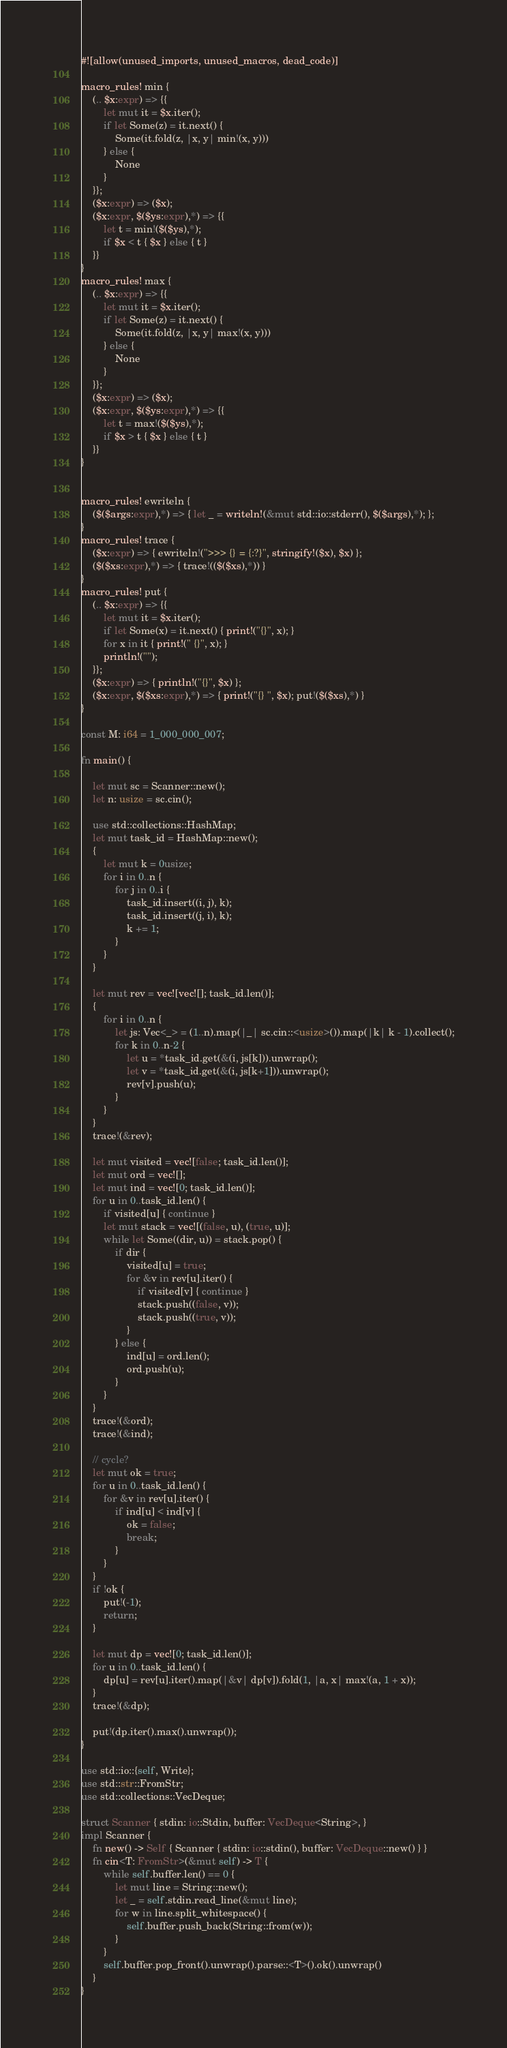<code> <loc_0><loc_0><loc_500><loc_500><_Rust_>#![allow(unused_imports, unused_macros, dead_code)]

macro_rules! min {
    (.. $x:expr) => {{
        let mut it = $x.iter();
        if let Some(z) = it.next() {
            Some(it.fold(z, |x, y| min!(x, y)))
        } else {
            None
        }
    }};
    ($x:expr) => ($x);
    ($x:expr, $($ys:expr),*) => {{
        let t = min!($($ys),*);
        if $x < t { $x } else { t }
    }}
}
macro_rules! max {
    (.. $x:expr) => {{
        let mut it = $x.iter();
        if let Some(z) = it.next() {
            Some(it.fold(z, |x, y| max!(x, y)))
        } else {
            None
        }
    }};
    ($x:expr) => ($x);
    ($x:expr, $($ys:expr),*) => {{
        let t = max!($($ys),*);
        if $x > t { $x } else { t }
    }}
}


macro_rules! ewriteln {
    ($($args:expr),*) => { let _ = writeln!(&mut std::io::stderr(), $($args),*); };
}
macro_rules! trace {
    ($x:expr) => { ewriteln!(">>> {} = {:?}", stringify!($x), $x) };
    ($($xs:expr),*) => { trace!(($($xs),*)) }
}
macro_rules! put {
    (.. $x:expr) => {{
        let mut it = $x.iter();
        if let Some(x) = it.next() { print!("{}", x); }
        for x in it { print!(" {}", x); }
        println!("");
    }};
    ($x:expr) => { println!("{}", $x) };
    ($x:expr, $($xs:expr),*) => { print!("{} ", $x); put!($($xs),*) }
}

const M: i64 = 1_000_000_007;

fn main() {

    let mut sc = Scanner::new();
    let n: usize = sc.cin();

    use std::collections::HashMap;
    let mut task_id = HashMap::new();
    {
        let mut k = 0usize;
        for i in 0..n {
            for j in 0..i {
                task_id.insert((i, j), k);
                task_id.insert((j, i), k);
                k += 1;
            }
        }
    }

    let mut rev = vec![vec![]; task_id.len()];
    {
        for i in 0..n {
            let js: Vec<_> = (1..n).map(|_| sc.cin::<usize>()).map(|k| k - 1).collect();
            for k in 0..n-2 {
                let u = *task_id.get(&(i, js[k])).unwrap();
                let v = *task_id.get(&(i, js[k+1])).unwrap();
                rev[v].push(u);
            }
        }
    }
    trace!(&rev);

    let mut visited = vec![false; task_id.len()];
    let mut ord = vec![];
    let mut ind = vec![0; task_id.len()];
    for u in 0..task_id.len() {
        if visited[u] { continue }
        let mut stack = vec![(false, u), (true, u)];
        while let Some((dir, u)) = stack.pop() {
            if dir {
                visited[u] = true;
                for &v in rev[u].iter() {
                    if visited[v] { continue }
                    stack.push((false, v));
                    stack.push((true, v));
                }
            } else {
                ind[u] = ord.len();
                ord.push(u);
            }
        }
    }
    trace!(&ord);
    trace!(&ind);

    // cycle?
    let mut ok = true;
    for u in 0..task_id.len() {
        for &v in rev[u].iter() {
            if ind[u] < ind[v] {
                ok = false;
                break;
            }
        }
    }
    if !ok {
        put!(-1);
        return;
    }

    let mut dp = vec![0; task_id.len()];
    for u in 0..task_id.len() {
        dp[u] = rev[u].iter().map(|&v| dp[v]).fold(1, |a, x| max!(a, 1 + x));
    }
    trace!(&dp);

    put!(dp.iter().max().unwrap());
}

use std::io::{self, Write};
use std::str::FromStr;
use std::collections::VecDeque;

struct Scanner { stdin: io::Stdin, buffer: VecDeque<String>, }
impl Scanner {
    fn new() -> Self { Scanner { stdin: io::stdin(), buffer: VecDeque::new() } }
    fn cin<T: FromStr>(&mut self) -> T {
        while self.buffer.len() == 0 {
            let mut line = String::new();
            let _ = self.stdin.read_line(&mut line);
            for w in line.split_whitespace() {
                self.buffer.push_back(String::from(w));
            }
        }
        self.buffer.pop_front().unwrap().parse::<T>().ok().unwrap()
    }
}
</code> 